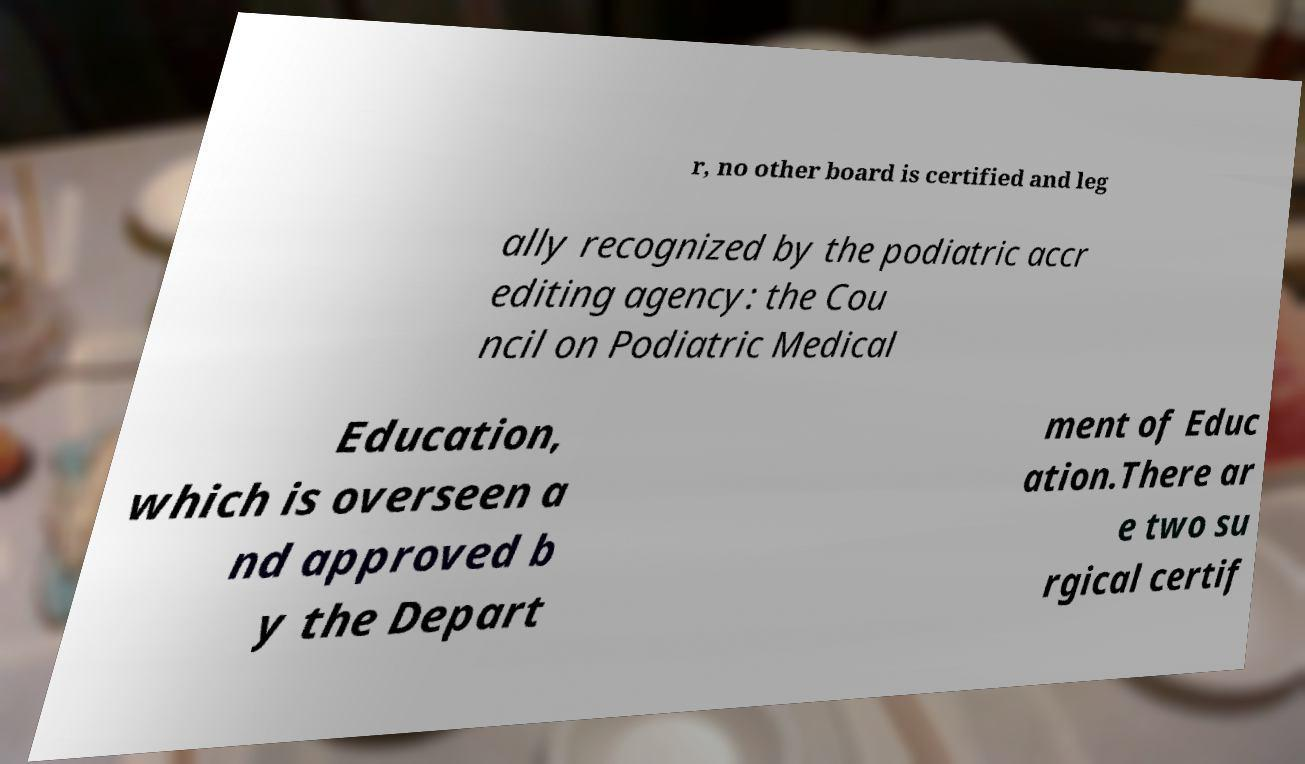Please read and relay the text visible in this image. What does it say? r, no other board is certified and leg ally recognized by the podiatric accr editing agency: the Cou ncil on Podiatric Medical Education, which is overseen a nd approved b y the Depart ment of Educ ation.There ar e two su rgical certif 